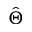Convert formula to latex. <formula><loc_0><loc_0><loc_500><loc_500>\hat { \Theta }</formula> 